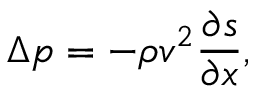<formula> <loc_0><loc_0><loc_500><loc_500>\Delta p = - \rho v ^ { 2 } { \frac { \partial s } { \partial x } } ,</formula> 